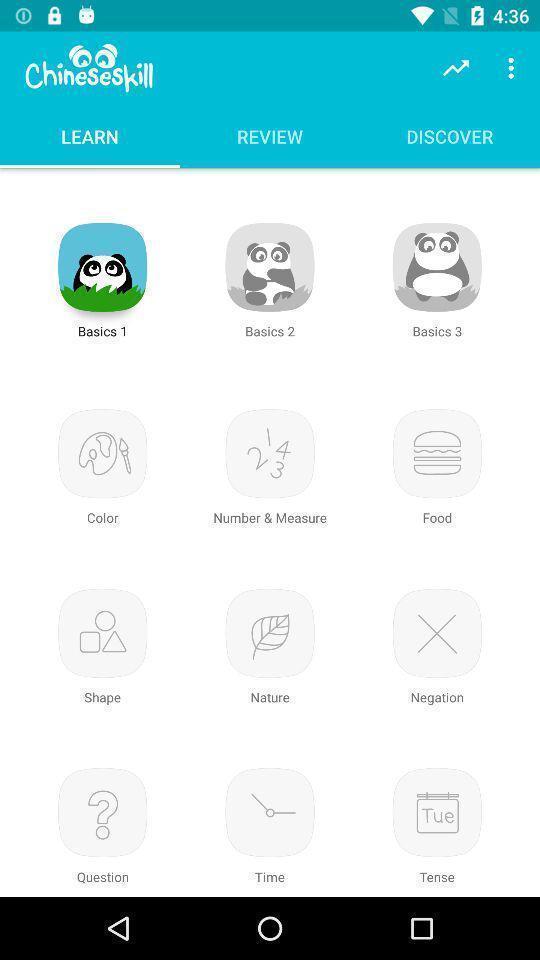Give me a narrative description of this picture. Page displaying list of categories to learn. 